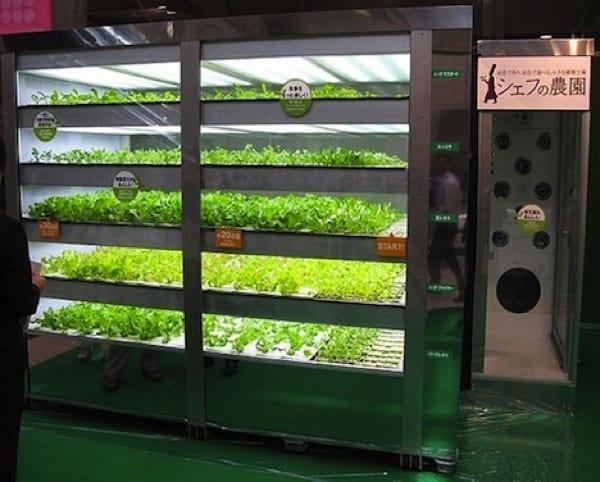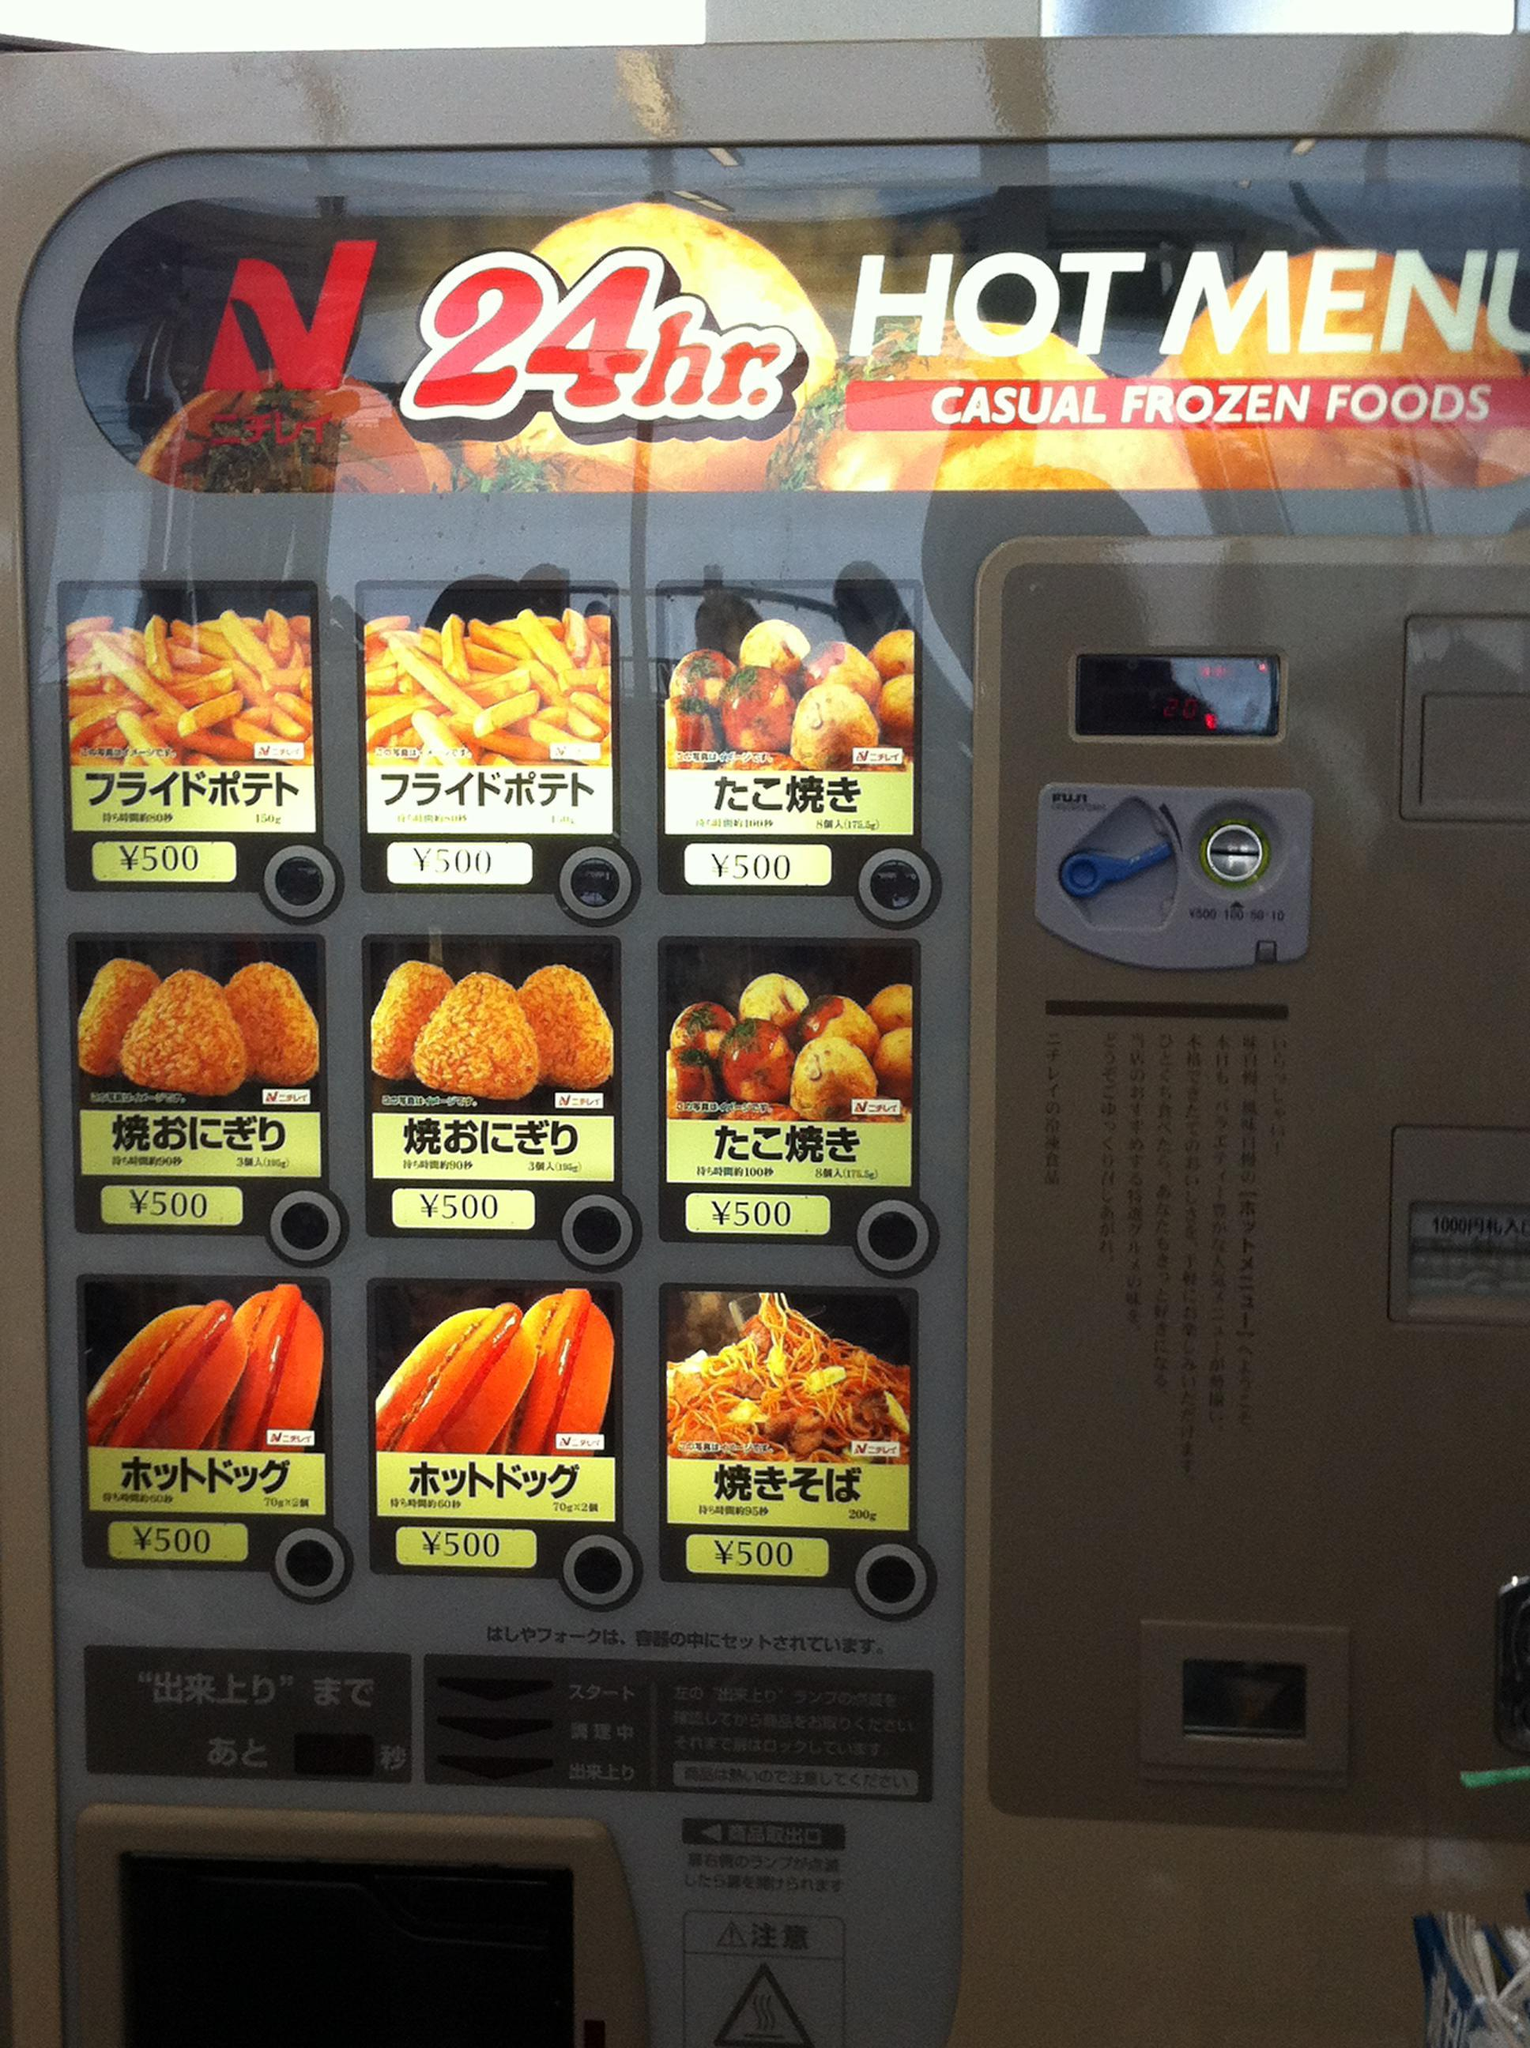The first image is the image on the left, the second image is the image on the right. Considering the images on both sides, is "An image shows a row of red, white and blue vending machines." valid? Answer yes or no. No. The first image is the image on the left, the second image is the image on the right. Assess this claim about the two images: "At least one of the machines is bright red.". Correct or not? Answer yes or no. No. 